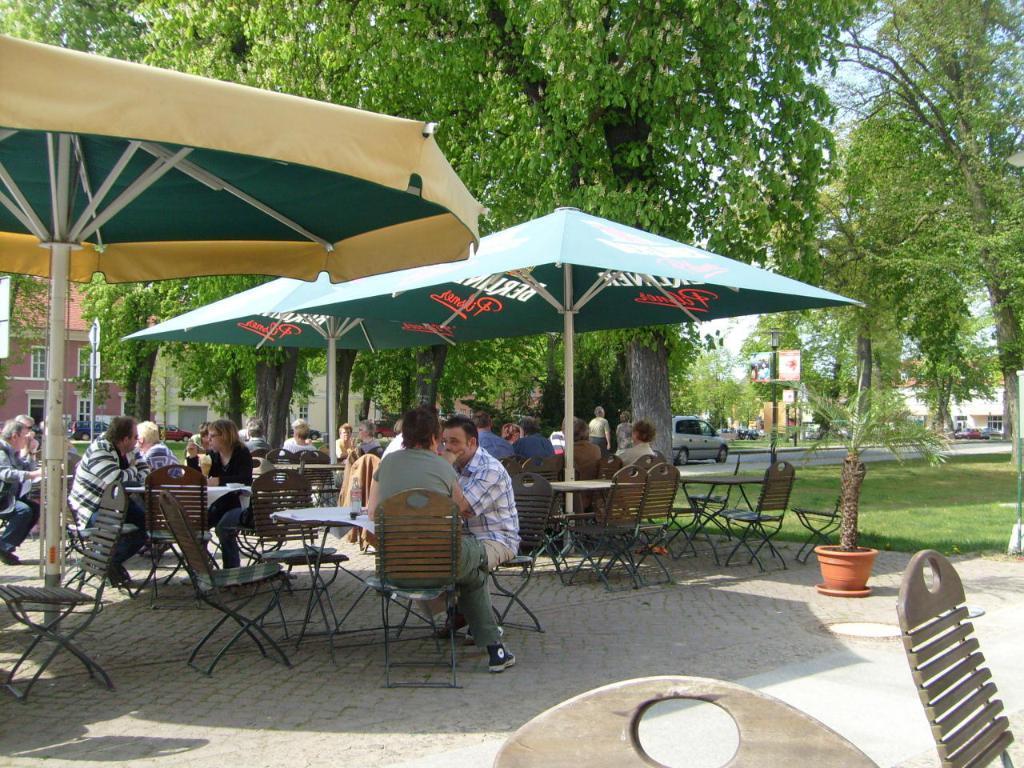Please provide a concise description of this image. In the center of the image we can see persons sitting on the chairs under umbrellas. In the background we can see trees, car, road, buildings and sky. 